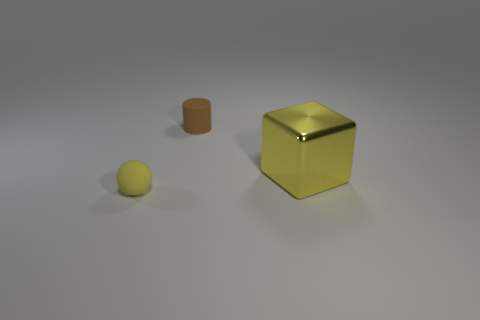Can you describe the texture of the objects in the image? Certainly! The large block appears to have a smooth, reflective metallic surface, likely indicating it's made of a polished metal. The smaller objects, including the ball and the cylinder, seem to have a matte finish, suggesting a textured or non-reflective material. 